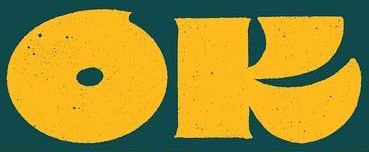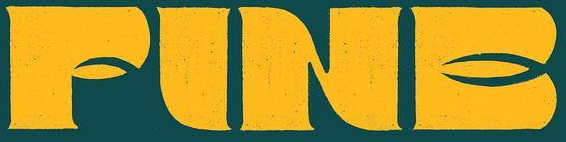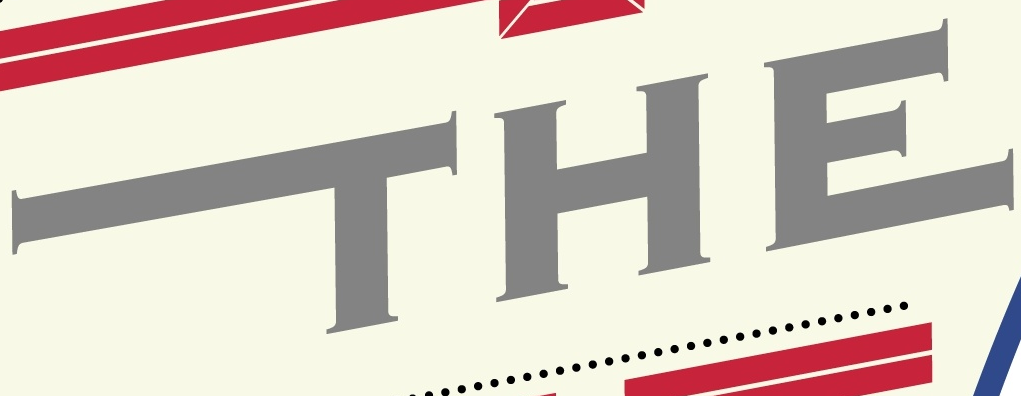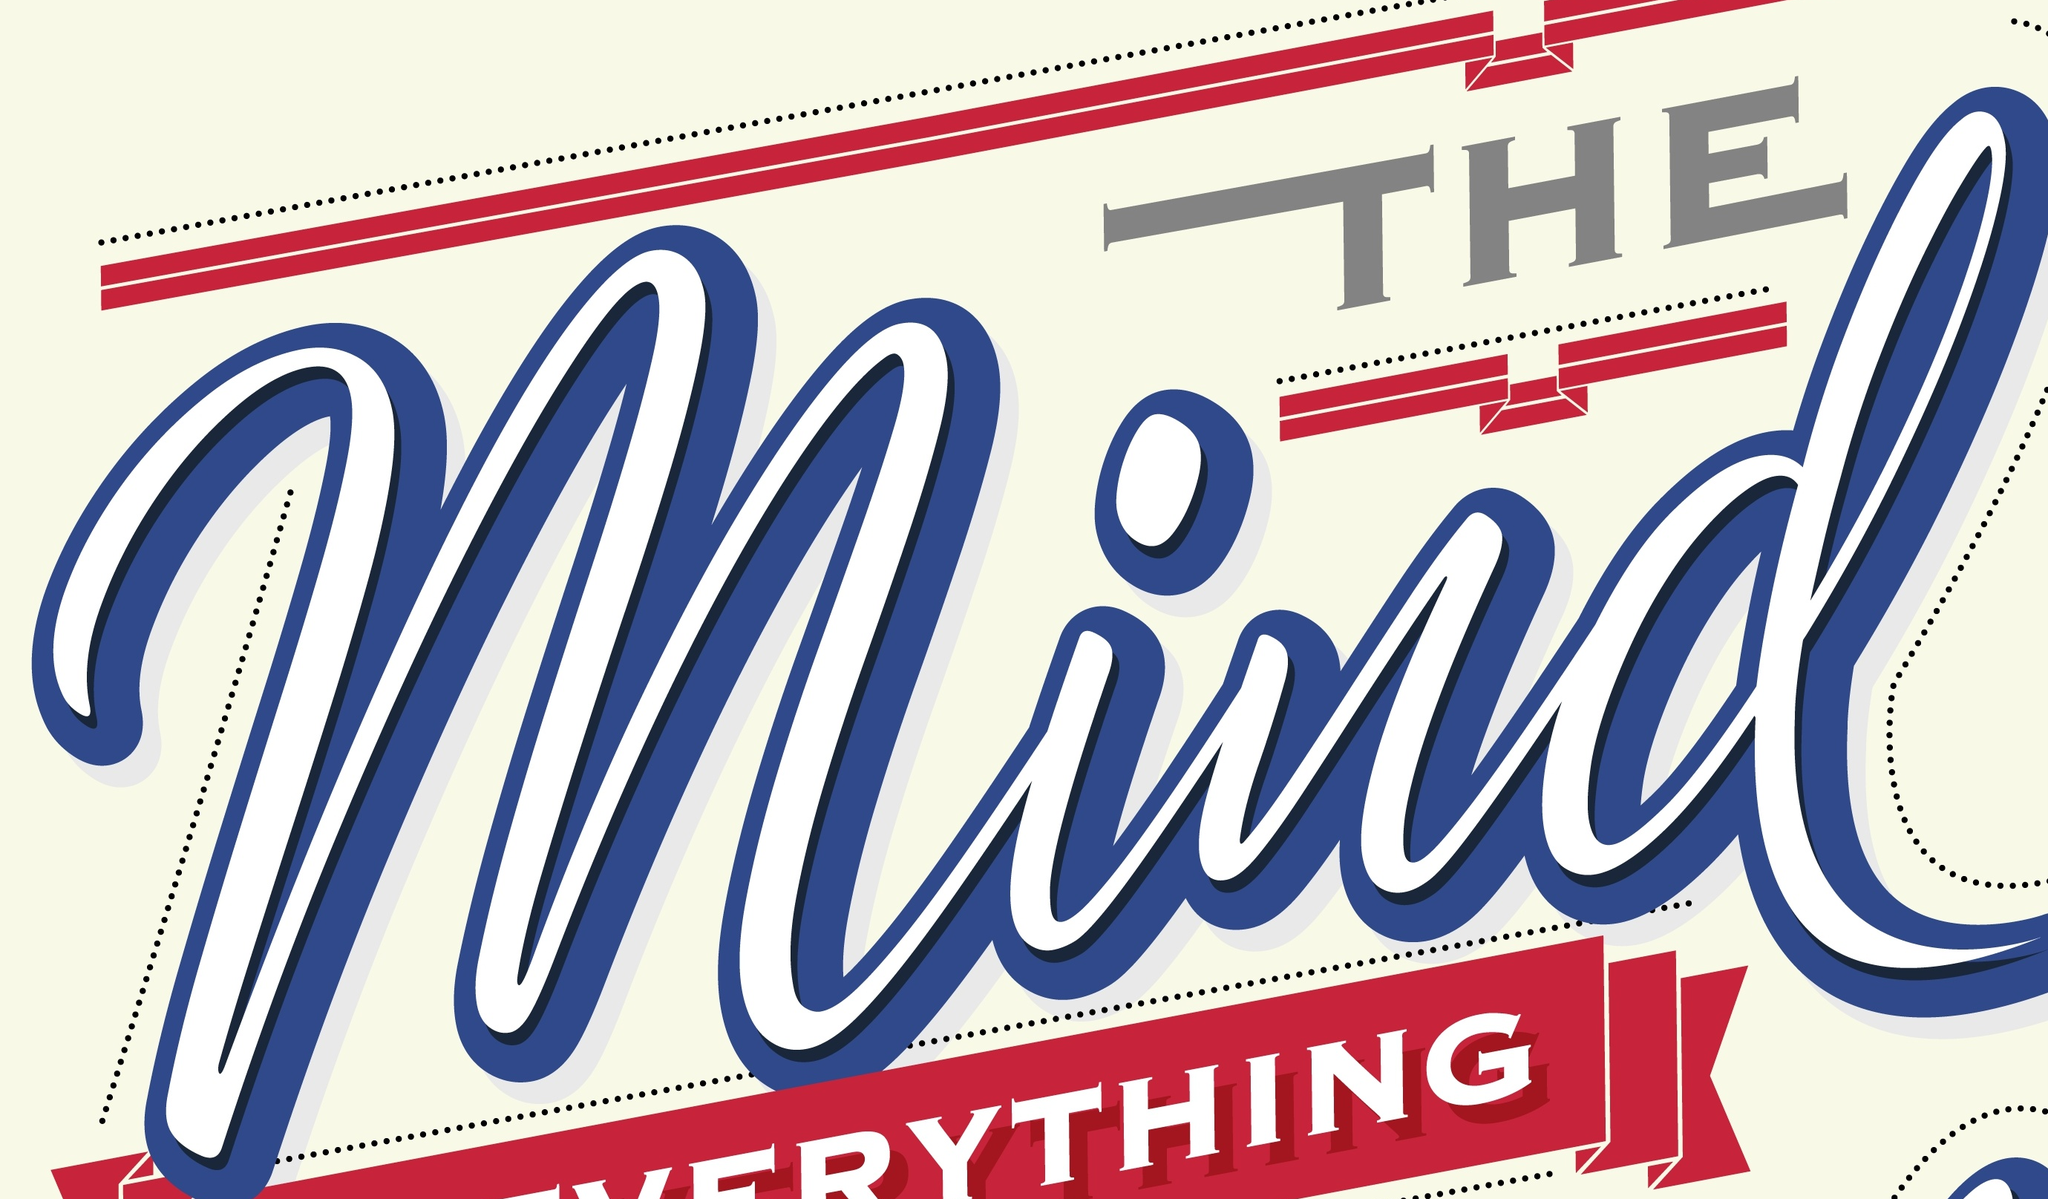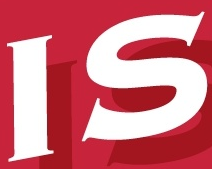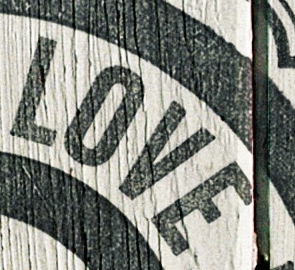Read the text content from these images in order, separated by a semicolon. OK; FINE; THE; Mind; IS; LOVE 